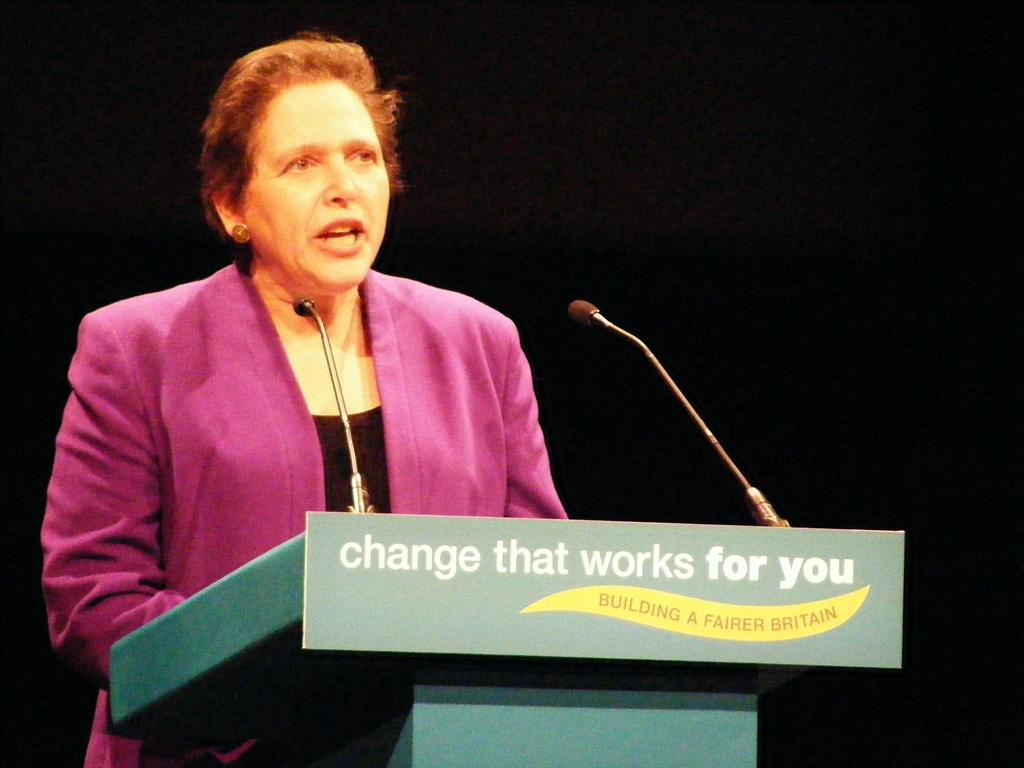What is the person in the image doing? The person is standing in front of the podium and talking. What is on the podium? There is a board on the podium. How is the person's voice being amplified? There is a microphone attached to the podium. What can be observed about the lighting in the image? The background of the image is dark. What type of loaf can be seen on the edge of the podium in the image? There is no loaf present on the edge of the podium in the image. What season is depicted in the image? The image does not depict a specific season; it only shows a person standing in front of a podium with a dark background. 